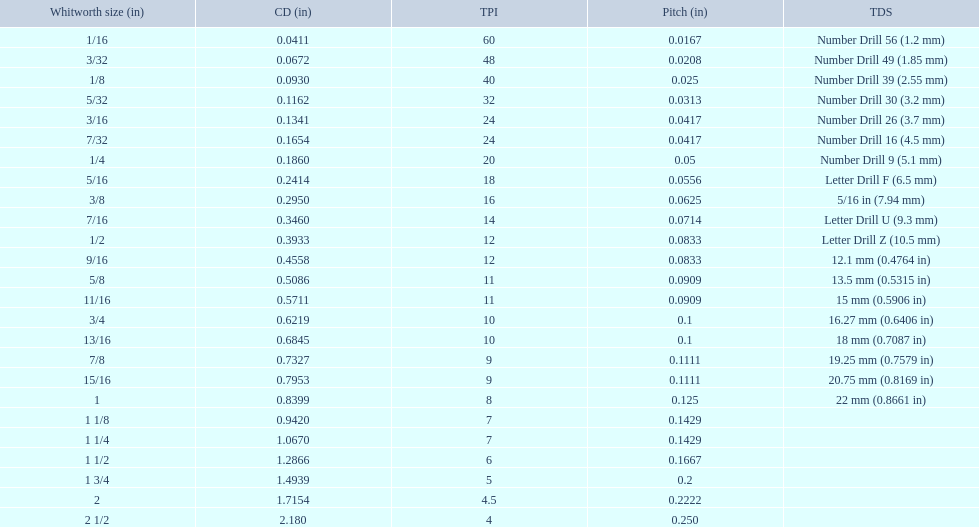What are the whitworth sizes? 1/16, 3/32, 1/8, 5/32, 3/16, 7/32, 1/4, 5/16, 3/8, 7/16, 1/2, 9/16, 5/8, 11/16, 3/4, 13/16, 7/8, 15/16, 1, 1 1/8, 1 1/4, 1 1/2, 1 3/4, 2, 2 1/2. And their threads per inch? 60, 48, 40, 32, 24, 24, 20, 18, 16, 14, 12, 12, 11, 11, 10, 10, 9, 9, 8, 7, 7, 6, 5, 4.5, 4. Now, which whitworth size has a thread-per-inch size of 5?? 1 3/4. 